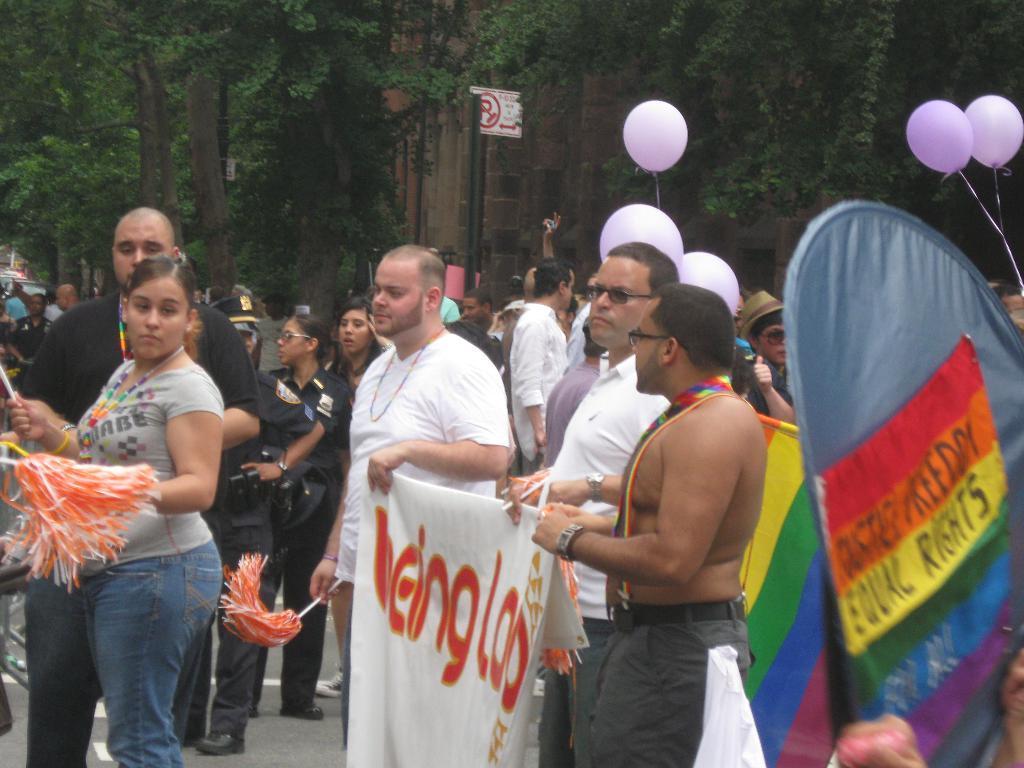Please provide a concise description of this image. This image consists of many people. In the front, we can see two men holding a banner. In the background, there are many trees and balloons. At the bottom, it looks like a road. On the right, it looks like a placard. 